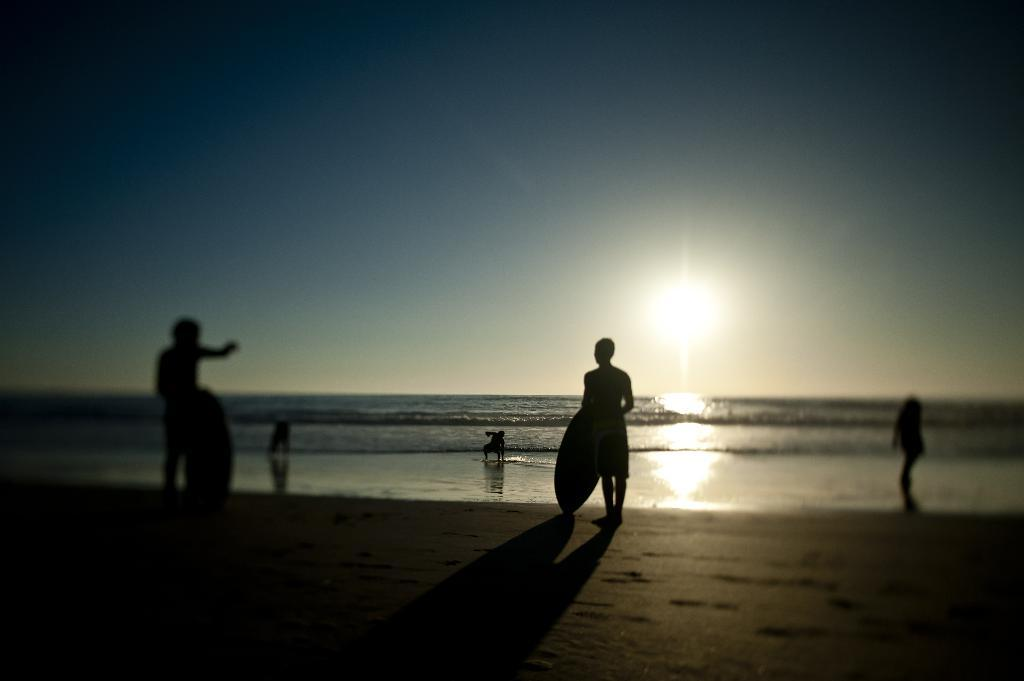Where is the location of the image? The image is taken at the sea shore. What can be seen in the image besides the sea shore? There are people standing in the image. What are the people holding in the image? The people are holding objects. What is the color of the sky in the image? The sky is white in color. What celestial body is visible in the image? The sun is visible in the image and is also white in color. Can you see a woman holding a snail on the farm in the image? There is no woman, snail, or farm present in the image; it is taken at the sea shore. 